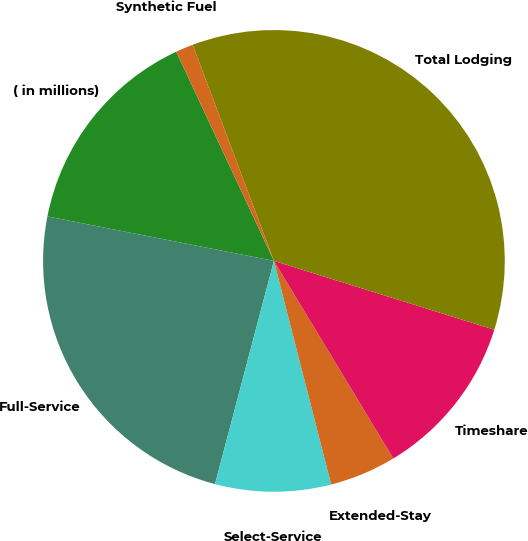Convert chart. <chart><loc_0><loc_0><loc_500><loc_500><pie_chart><fcel>( in millions)<fcel>Full-Service<fcel>Select-Service<fcel>Extended-Stay<fcel>Timeshare<fcel>Total Lodging<fcel>Synthetic Fuel<nl><fcel>14.96%<fcel>23.98%<fcel>8.1%<fcel>4.66%<fcel>11.53%<fcel>35.55%<fcel>1.23%<nl></chart> 